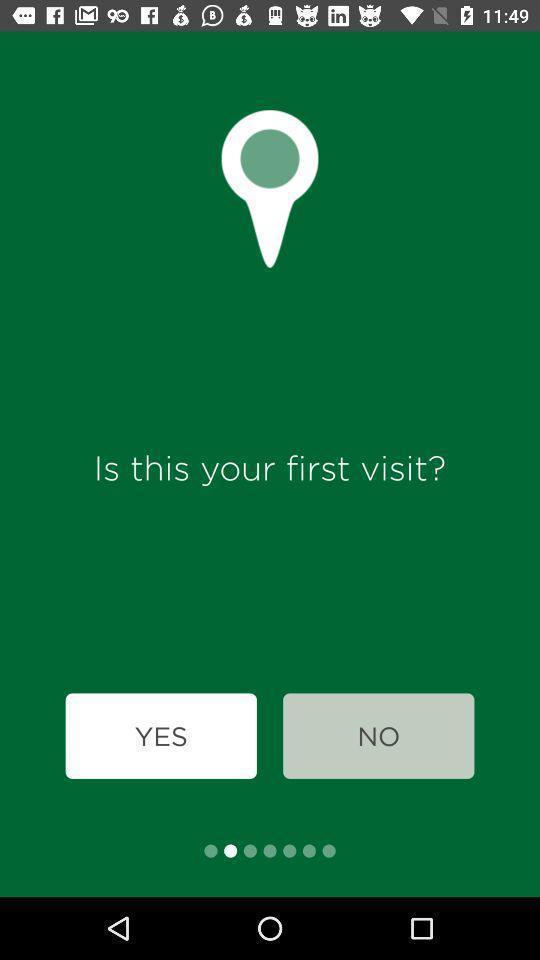Explain the elements present in this screenshot. Starting page. 